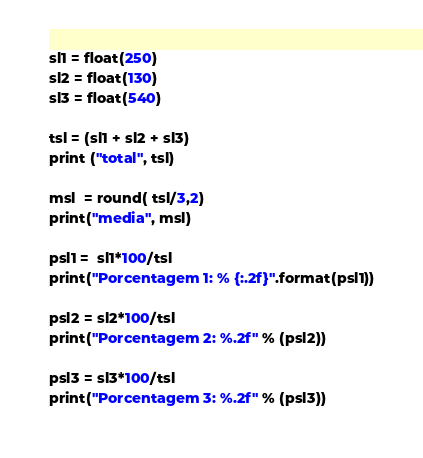<code> <loc_0><loc_0><loc_500><loc_500><_Python_>sl1 = float(250)
sl2 = float(130)
sl3 = float(540)

tsl = (sl1 + sl2 + sl3)
print ("total", tsl)

msl  = round( tsl/3,2)
print("media", msl)

psl1 =  sl1*100/tsl
print("Porcentagem 1: % {:.2f}".format(psl1))

psl2 = sl2*100/tsl
print("Porcentagem 2: %.2f" % (psl2))

psl3 = sl3*100/tsl
print("Porcentagem 3: %.2f" % (psl3))

</code> 